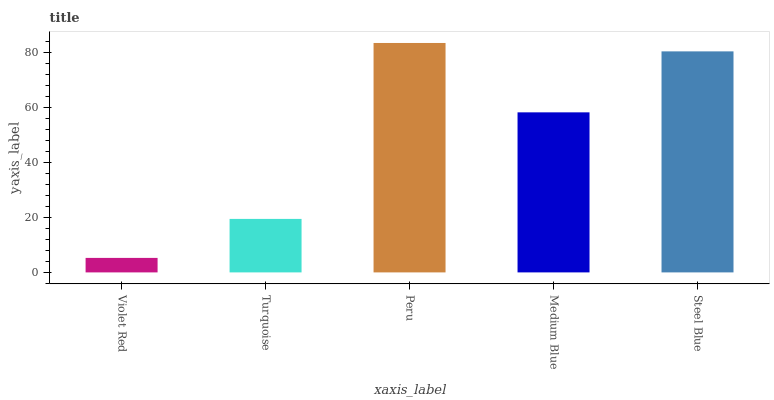Is Violet Red the minimum?
Answer yes or no. Yes. Is Peru the maximum?
Answer yes or no. Yes. Is Turquoise the minimum?
Answer yes or no. No. Is Turquoise the maximum?
Answer yes or no. No. Is Turquoise greater than Violet Red?
Answer yes or no. Yes. Is Violet Red less than Turquoise?
Answer yes or no. Yes. Is Violet Red greater than Turquoise?
Answer yes or no. No. Is Turquoise less than Violet Red?
Answer yes or no. No. Is Medium Blue the high median?
Answer yes or no. Yes. Is Medium Blue the low median?
Answer yes or no. Yes. Is Peru the high median?
Answer yes or no. No. Is Turquoise the low median?
Answer yes or no. No. 